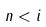<formula> <loc_0><loc_0><loc_500><loc_500>n < i</formula> 